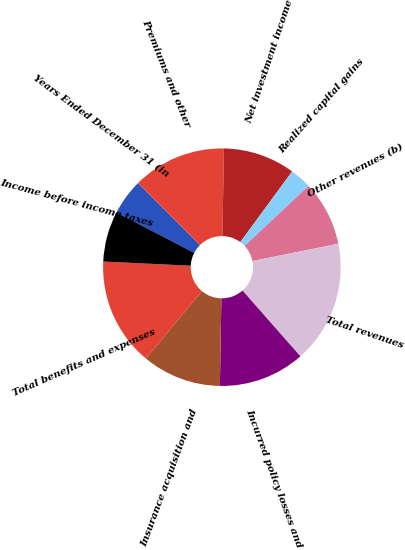Convert chart. <chart><loc_0><loc_0><loc_500><loc_500><pie_chart><fcel>Years Ended December 31 (in<fcel>Premiums and other<fcel>Net investment income<fcel>Realized capital gains<fcel>Other revenues (b)<fcel>Total revenues<fcel>Incurred policy losses and<fcel>Insurance acquisition and<fcel>Total benefits and expenses<fcel>Income before income taxes<nl><fcel>4.9%<fcel>12.75%<fcel>9.8%<fcel>2.94%<fcel>8.82%<fcel>16.67%<fcel>11.76%<fcel>10.78%<fcel>14.71%<fcel>6.86%<nl></chart> 